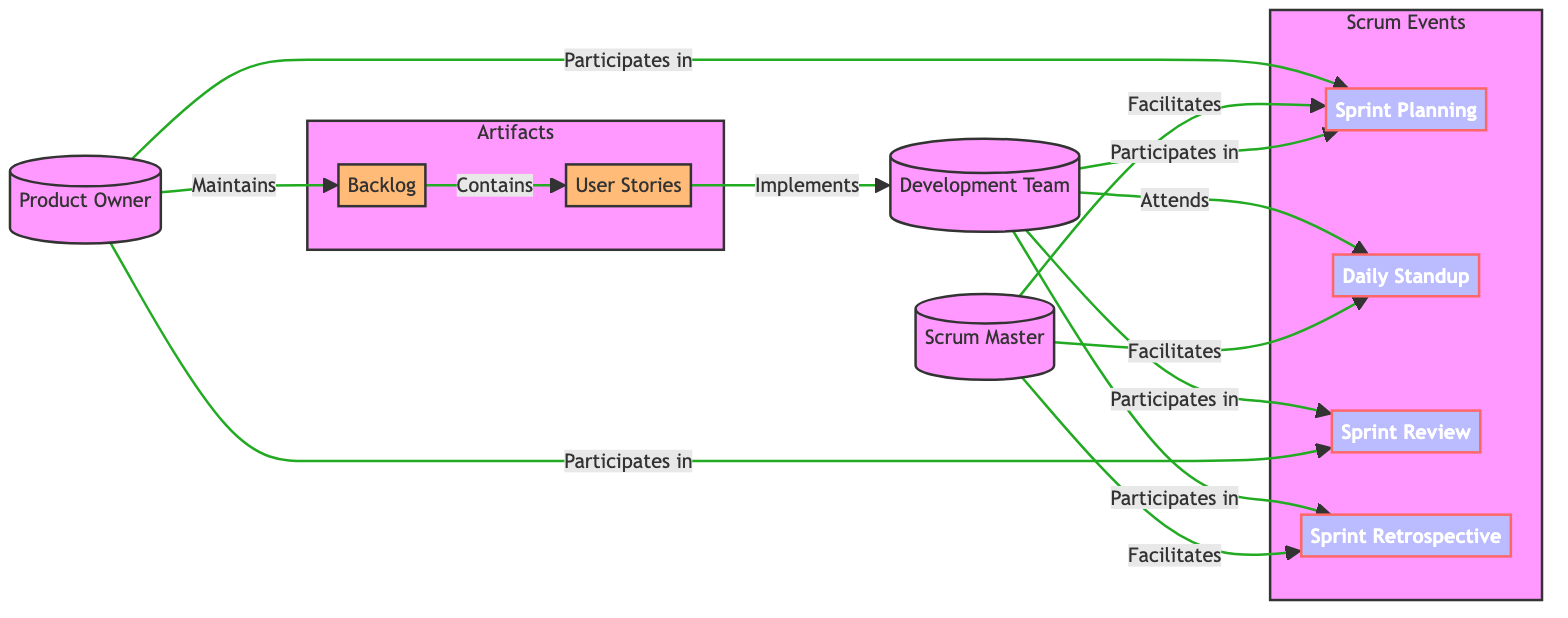What is the role of the person identified as "Product Owner"? The "Product Owner" is identified as maintaining the "Backlog" in the diagram, indicating their responsibility for prioritizing and managing product features and requirements.
Answer: Maintains How many main roles are defined in the diagram? The diagram specifies three main roles: "Product Owner," "Scrum Master," and "Development Team." Counting these roles gives a total of three.
Answer: Three Which event is facilitated by both the "Scrum Master" and the "Development Team"? The "Daily Standup" is an event that both the "Scrum Master" facilitates and in which the "Development Team" participates, as indicated by their connections in the diagram.
Answer: Daily Standup What artifact contains "User Stories"? The artifact identified in the diagram that contains "User Stories" is the "Backlog." This is shown by the direct relationship connecting the two nodes.
Answer: Backlog Which event follows the "Sprint Review"? In the order of events presented in the diagram, the "Sprint Retrospective" follows the "Sprint Review." This can be deduced from the positioning of the events in the flow.
Answer: Sprint Retrospective What does the "Development Team" implement according to the diagram? The "Development Team" implements "User Stories," which are contained in the "Backlog," as per the edges linking these elements in the diagram.
Answer: User Stories How many events are shown in the diagram? There are four events depicted in the diagram: "Sprint Planning," "Daily Standup," "Sprint Review," and "Sprint Retrospective." Simple counting of these nodes gives a total of four.
Answer: Four Who participates in the "Sprint Planning" session? The "Product Owner," "Scrum Master," and "Development Team" all participate in the "Sprint Planning" session, as indicated by the direct connections in the diagram.
Answer: Product Owner, Scrum Master, Development Team What type of communication is facilitated by the "Scrum Master"? The "Scrum Master" facilitates multiple events, including "Sprint Planning," "Daily Standup," and "Sprint Retrospective," indicating their role in enabling effective communication within the team.
Answer: Facilitates What is the direct relationship between "Backlog" and "User Stories"? The direct relationship is that the "Backlog" contains "User Stories," as shown by the edge connecting these two nodes in the diagram.
Answer: Contains 